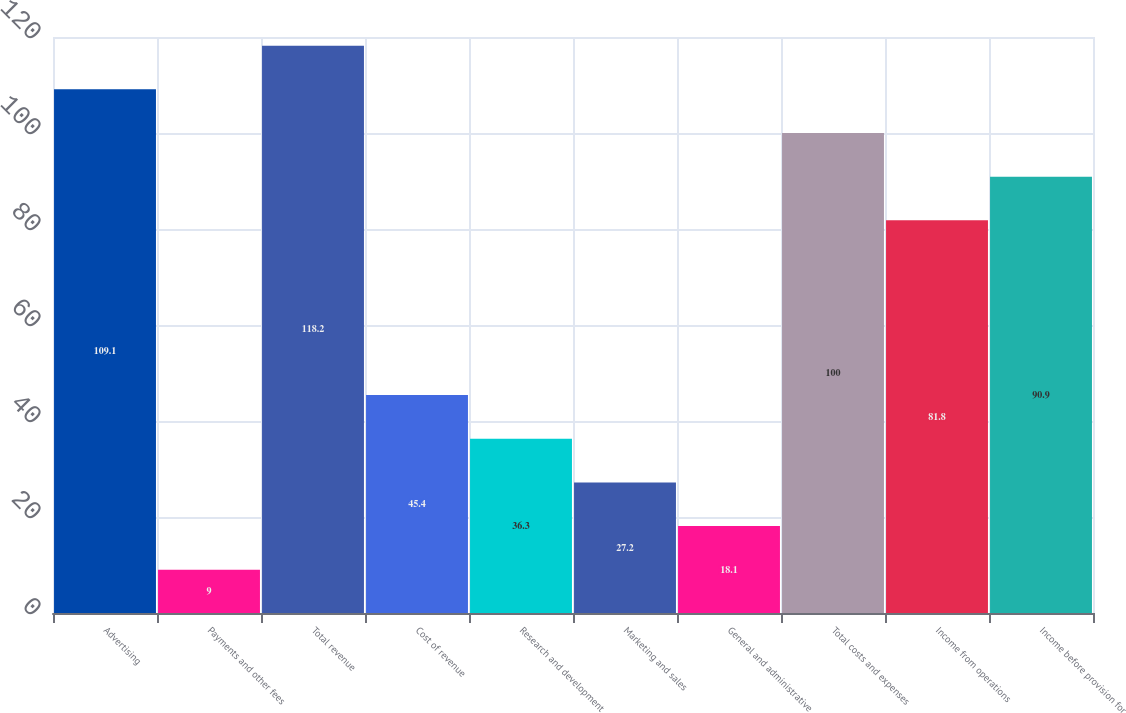Convert chart. <chart><loc_0><loc_0><loc_500><loc_500><bar_chart><fcel>Advertising<fcel>Payments and other fees<fcel>Total revenue<fcel>Cost of revenue<fcel>Research and development<fcel>Marketing and sales<fcel>General and administrative<fcel>Total costs and expenses<fcel>Income from operations<fcel>Income before provision for<nl><fcel>109.1<fcel>9<fcel>118.2<fcel>45.4<fcel>36.3<fcel>27.2<fcel>18.1<fcel>100<fcel>81.8<fcel>90.9<nl></chart> 